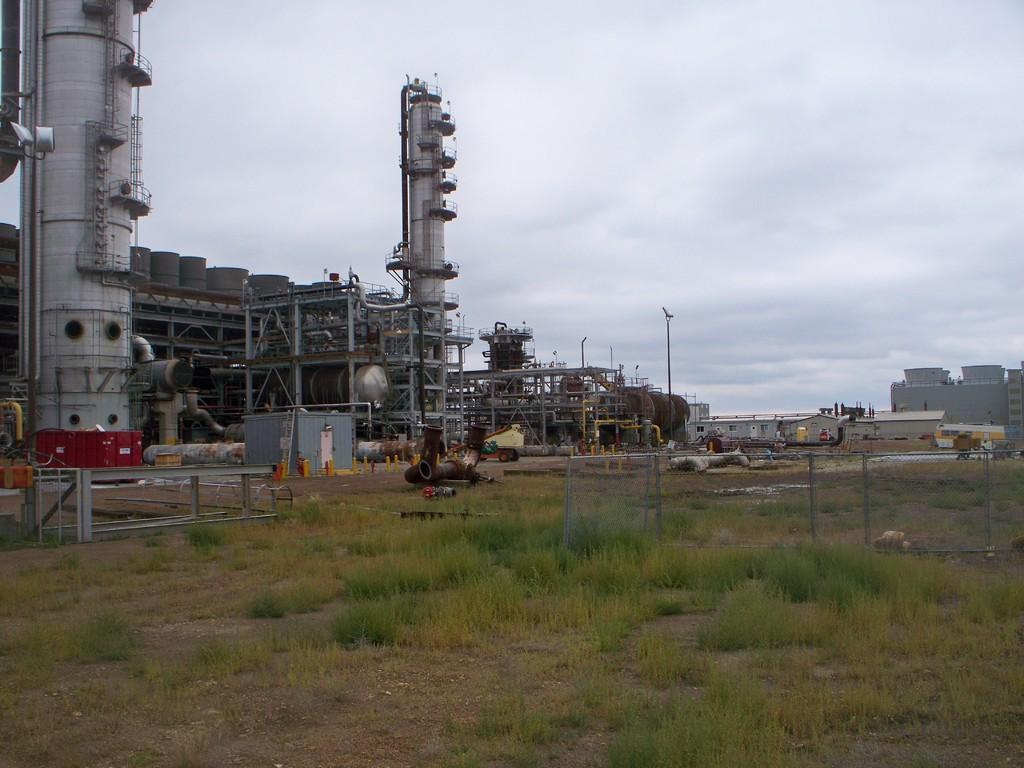What type of terrain is at the bottom of the image? There is grass at the bottom of the image. What can be seen on the left side of the image? There are machines on the left side of the image. What is visible at the top of the image? The sky is visible at the top of the image. What type of experience can be gained from the army in the image? There is no army present in the image, so no such experience can be gained. How does the image show an increase in productivity? The image does not show an increase in productivity; it only depicts grass, machines, and the sky. 